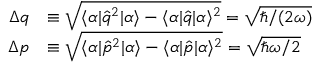Convert formula to latex. <formula><loc_0><loc_0><loc_500><loc_500>\begin{array} { r l } { \Delta q } & { \equiv \sqrt { \langle \alpha | \hat { q } ^ { 2 } | \alpha \rangle - \langle \alpha | \hat { q } | \alpha \rangle ^ { 2 } } = \sqrt { \hbar { / } ( 2 \omega ) } } \\ { \Delta p } & { \equiv \sqrt { \langle \alpha | \hat { p } ^ { 2 } | \alpha \rangle - \langle \alpha | \hat { p } | \alpha \rangle ^ { 2 } } = \sqrt { \hbar { \omega } / 2 } } \end{array}</formula> 